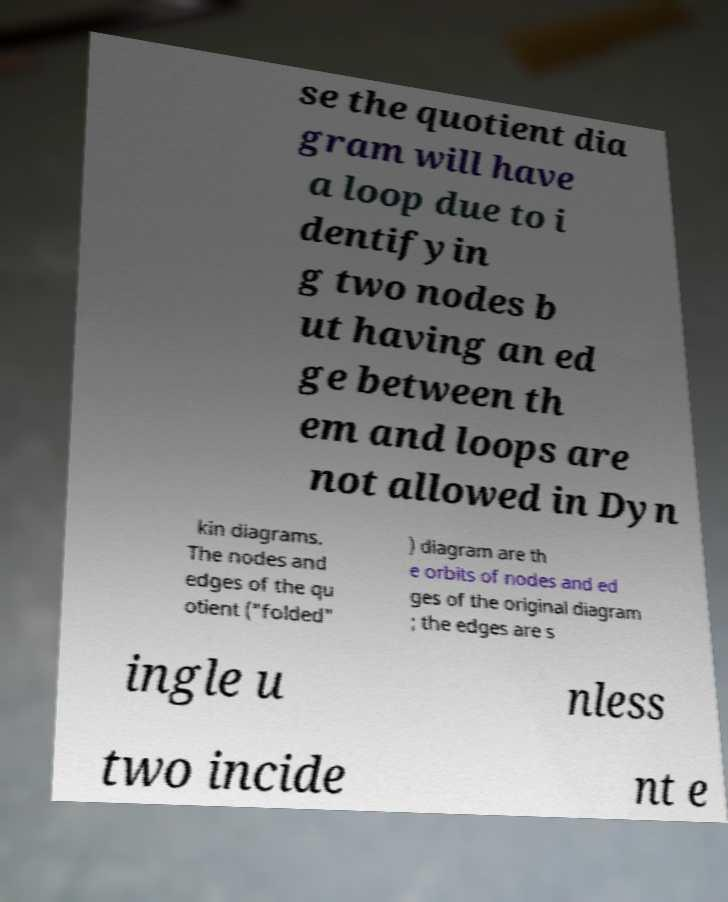Can you accurately transcribe the text from the provided image for me? se the quotient dia gram will have a loop due to i dentifyin g two nodes b ut having an ed ge between th em and loops are not allowed in Dyn kin diagrams. The nodes and edges of the qu otient ("folded" ) diagram are th e orbits of nodes and ed ges of the original diagram ; the edges are s ingle u nless two incide nt e 